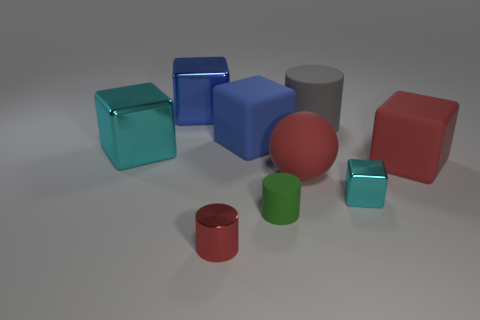Subtract all red cubes. How many cubes are left? 4 Subtract all blue metal cubes. How many cubes are left? 4 Subtract 1 cylinders. How many cylinders are left? 2 Subtract all gray cubes. Subtract all green spheres. How many cubes are left? 5 Add 1 red cubes. How many objects exist? 10 Subtract all balls. How many objects are left? 8 Subtract 1 green cylinders. How many objects are left? 8 Subtract all large cyan objects. Subtract all blue blocks. How many objects are left? 6 Add 9 big matte cylinders. How many big matte cylinders are left? 10 Add 1 large gray things. How many large gray things exist? 2 